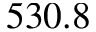<formula> <loc_0><loc_0><loc_500><loc_500>5 3 0 . 8</formula> 